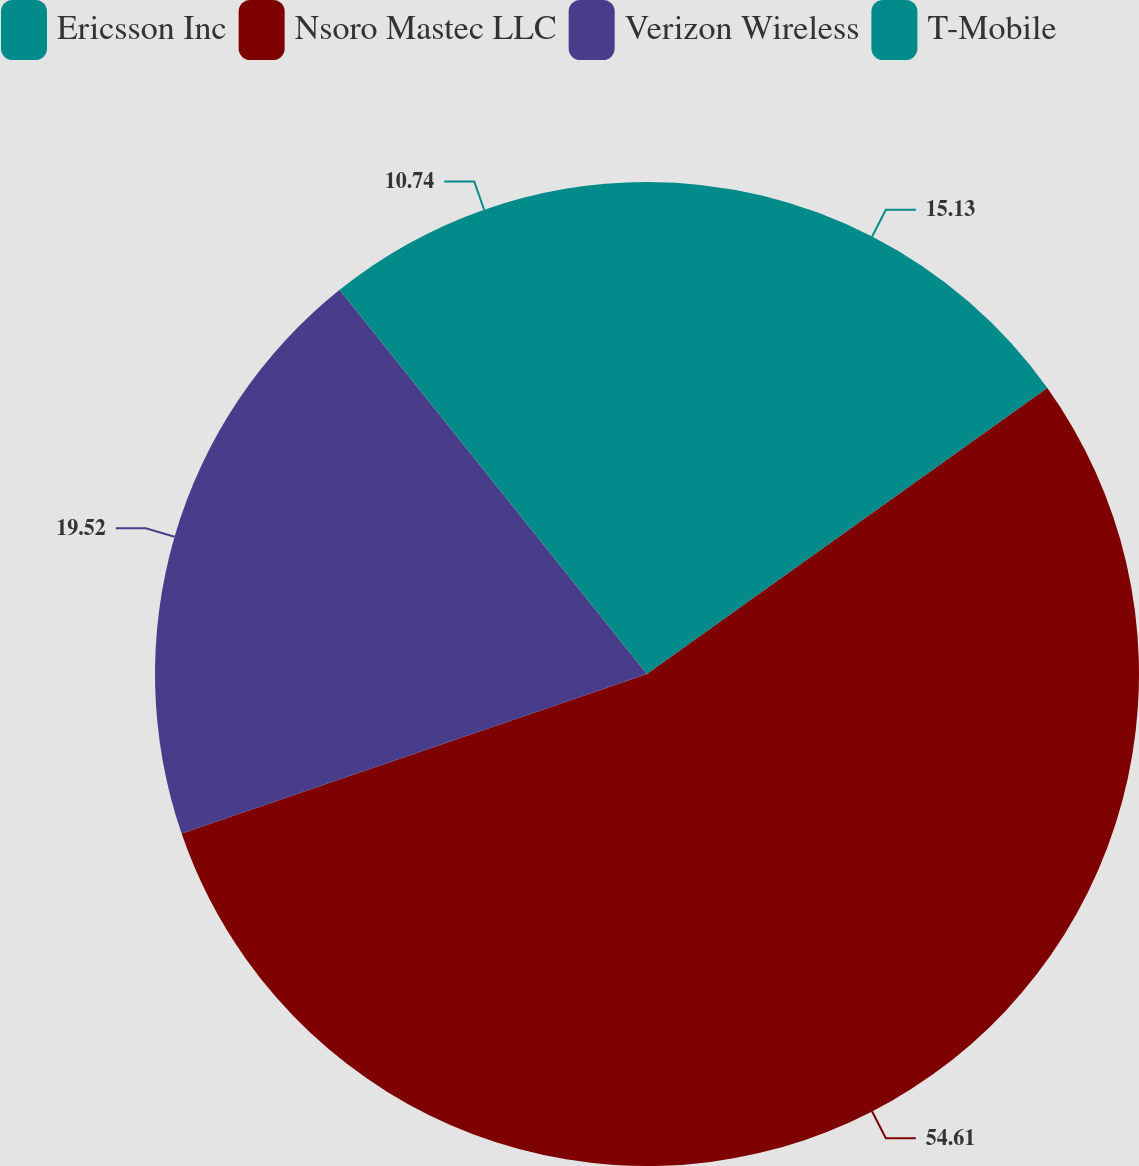Convert chart. <chart><loc_0><loc_0><loc_500><loc_500><pie_chart><fcel>Ericsson Inc<fcel>Nsoro Mastec LLC<fcel>Verizon Wireless<fcel>T-Mobile<nl><fcel>15.13%<fcel>54.62%<fcel>19.52%<fcel>10.74%<nl></chart> 